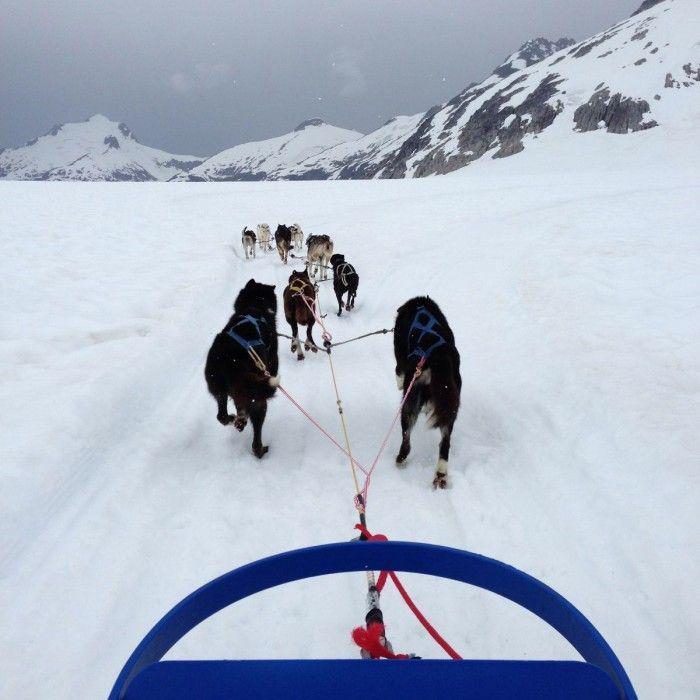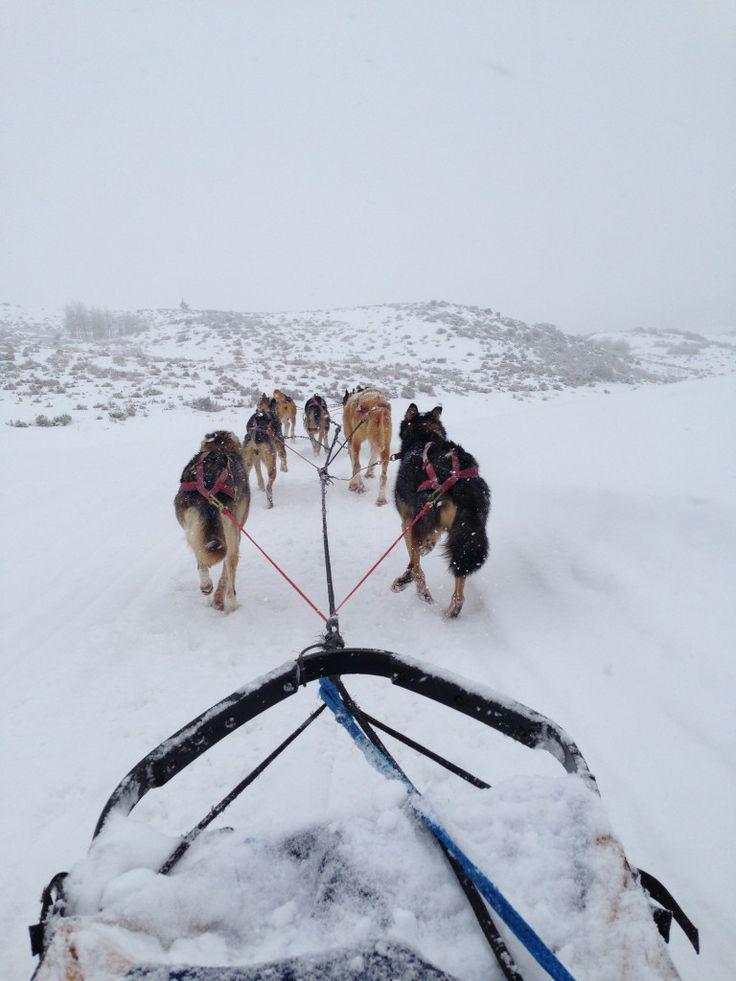The first image is the image on the left, the second image is the image on the right. Analyze the images presented: Is the assertion "At least one image shows a sled dog team headed straight, away from the camera." valid? Answer yes or no. Yes. The first image is the image on the left, the second image is the image on the right. For the images shown, is this caption "The sled on the snow in one of the images is empty." true? Answer yes or no. No. 